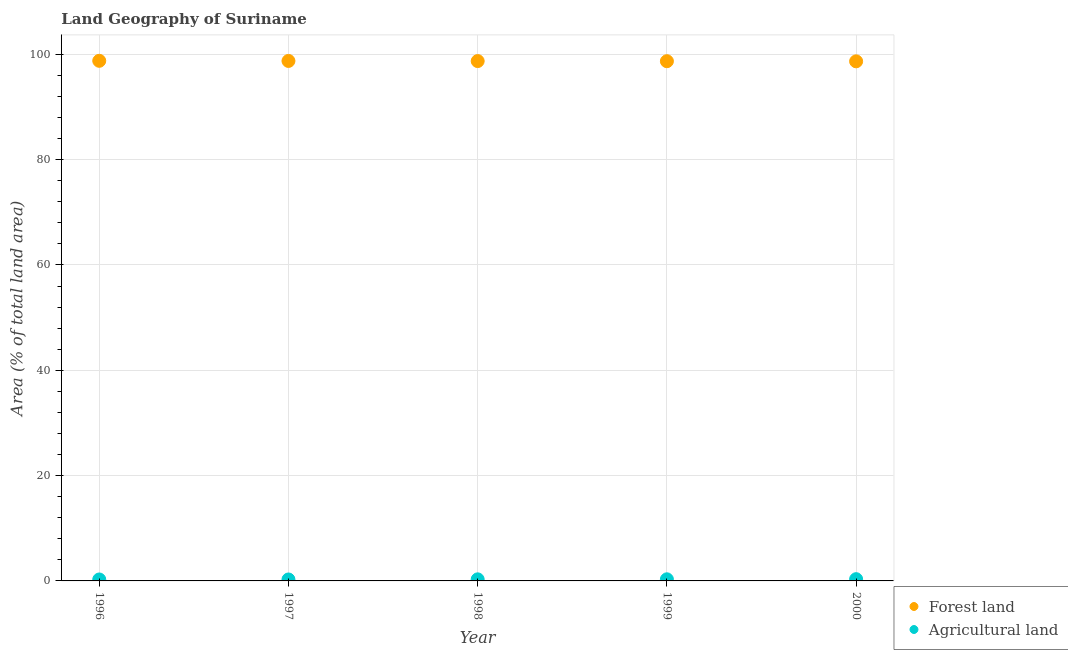What is the percentage of land area under agriculture in 1997?
Keep it short and to the point. 0.28. Across all years, what is the maximum percentage of land area under agriculture?
Make the answer very short. 0.33. Across all years, what is the minimum percentage of land area under forests?
Make the answer very short. 98.66. What is the total percentage of land area under forests in the graph?
Give a very brief answer. 493.55. What is the difference between the percentage of land area under forests in 1996 and that in 1998?
Ensure brevity in your answer.  0.05. What is the difference between the percentage of land area under forests in 2000 and the percentage of land area under agriculture in 1998?
Your response must be concise. 98.36. What is the average percentage of land area under forests per year?
Make the answer very short. 98.71. In the year 1996, what is the difference between the percentage of land area under agriculture and percentage of land area under forests?
Your answer should be very brief. -98.48. What is the ratio of the percentage of land area under forests in 1997 to that in 2000?
Offer a very short reply. 1. Is the percentage of land area under agriculture in 1997 less than that in 1999?
Offer a terse response. Yes. Is the difference between the percentage of land area under forests in 1999 and 2000 greater than the difference between the percentage of land area under agriculture in 1999 and 2000?
Your answer should be compact. Yes. What is the difference between the highest and the second highest percentage of land area under agriculture?
Ensure brevity in your answer.  0.03. What is the difference between the highest and the lowest percentage of land area under agriculture?
Your response must be concise. 0.06. In how many years, is the percentage of land area under agriculture greater than the average percentage of land area under agriculture taken over all years?
Your response must be concise. 3. Is the sum of the percentage of land area under agriculture in 1996 and 1998 greater than the maximum percentage of land area under forests across all years?
Keep it short and to the point. No. Is the percentage of land area under forests strictly greater than the percentage of land area under agriculture over the years?
Your answer should be very brief. Yes. What is the difference between two consecutive major ticks on the Y-axis?
Give a very brief answer. 20. How many legend labels are there?
Your answer should be very brief. 2. How are the legend labels stacked?
Keep it short and to the point. Vertical. What is the title of the graph?
Give a very brief answer. Land Geography of Suriname. Does "Males" appear as one of the legend labels in the graph?
Your response must be concise. No. What is the label or title of the X-axis?
Provide a succinct answer. Year. What is the label or title of the Y-axis?
Your answer should be compact. Area (% of total land area). What is the Area (% of total land area) of Forest land in 1996?
Offer a terse response. 98.76. What is the Area (% of total land area) in Agricultural land in 1996?
Your answer should be compact. 0.28. What is the Area (% of total land area) of Forest land in 1997?
Your answer should be very brief. 98.74. What is the Area (% of total land area) of Agricultural land in 1997?
Your answer should be very brief. 0.28. What is the Area (% of total land area) of Forest land in 1998?
Your answer should be very brief. 98.71. What is the Area (% of total land area) of Agricultural land in 1998?
Your answer should be compact. 0.3. What is the Area (% of total land area) in Forest land in 1999?
Your response must be concise. 98.69. What is the Area (% of total land area) of Agricultural land in 1999?
Give a very brief answer. 0.31. What is the Area (% of total land area) in Forest land in 2000?
Keep it short and to the point. 98.66. What is the Area (% of total land area) of Agricultural land in 2000?
Your answer should be compact. 0.33. Across all years, what is the maximum Area (% of total land area) of Forest land?
Give a very brief answer. 98.76. Across all years, what is the maximum Area (% of total land area) of Agricultural land?
Your answer should be very brief. 0.33. Across all years, what is the minimum Area (% of total land area) of Forest land?
Make the answer very short. 98.66. Across all years, what is the minimum Area (% of total land area) in Agricultural land?
Provide a short and direct response. 0.28. What is the total Area (% of total land area) in Forest land in the graph?
Offer a very short reply. 493.55. What is the total Area (% of total land area) in Agricultural land in the graph?
Your response must be concise. 1.49. What is the difference between the Area (% of total land area) in Forest land in 1996 and that in 1997?
Make the answer very short. 0.03. What is the difference between the Area (% of total land area) in Agricultural land in 1996 and that in 1997?
Ensure brevity in your answer.  0. What is the difference between the Area (% of total land area) in Forest land in 1996 and that in 1998?
Provide a short and direct response. 0.05. What is the difference between the Area (% of total land area) in Agricultural land in 1996 and that in 1998?
Offer a very short reply. -0.03. What is the difference between the Area (% of total land area) in Forest land in 1996 and that in 1999?
Your response must be concise. 0.07. What is the difference between the Area (% of total land area) of Agricultural land in 1996 and that in 1999?
Give a very brief answer. -0.03. What is the difference between the Area (% of total land area) in Forest land in 1996 and that in 2000?
Keep it short and to the point. 0.1. What is the difference between the Area (% of total land area) of Agricultural land in 1996 and that in 2000?
Ensure brevity in your answer.  -0.06. What is the difference between the Area (% of total land area) of Forest land in 1997 and that in 1998?
Make the answer very short. 0.03. What is the difference between the Area (% of total land area) of Agricultural land in 1997 and that in 1998?
Your answer should be compact. -0.03. What is the difference between the Area (% of total land area) in Forest land in 1997 and that in 1999?
Keep it short and to the point. 0.05. What is the difference between the Area (% of total land area) in Agricultural land in 1997 and that in 1999?
Offer a terse response. -0.03. What is the difference between the Area (% of total land area) of Forest land in 1997 and that in 2000?
Provide a succinct answer. 0.07. What is the difference between the Area (% of total land area) of Agricultural land in 1997 and that in 2000?
Offer a very short reply. -0.06. What is the difference between the Area (% of total land area) in Forest land in 1998 and that in 1999?
Keep it short and to the point. 0.03. What is the difference between the Area (% of total land area) in Agricultural land in 1998 and that in 1999?
Offer a terse response. -0.01. What is the difference between the Area (% of total land area) of Forest land in 1998 and that in 2000?
Offer a terse response. 0.05. What is the difference between the Area (% of total land area) of Agricultural land in 1998 and that in 2000?
Your response must be concise. -0.03. What is the difference between the Area (% of total land area) of Forest land in 1999 and that in 2000?
Offer a terse response. 0.03. What is the difference between the Area (% of total land area) of Agricultural land in 1999 and that in 2000?
Ensure brevity in your answer.  -0.03. What is the difference between the Area (% of total land area) in Forest land in 1996 and the Area (% of total land area) in Agricultural land in 1997?
Provide a short and direct response. 98.48. What is the difference between the Area (% of total land area) in Forest land in 1996 and the Area (% of total land area) in Agricultural land in 1998?
Your answer should be compact. 98.46. What is the difference between the Area (% of total land area) in Forest land in 1996 and the Area (% of total land area) in Agricultural land in 1999?
Make the answer very short. 98.45. What is the difference between the Area (% of total land area) of Forest land in 1996 and the Area (% of total land area) of Agricultural land in 2000?
Your answer should be compact. 98.43. What is the difference between the Area (% of total land area) of Forest land in 1997 and the Area (% of total land area) of Agricultural land in 1998?
Offer a terse response. 98.43. What is the difference between the Area (% of total land area) of Forest land in 1997 and the Area (% of total land area) of Agricultural land in 1999?
Make the answer very short. 98.43. What is the difference between the Area (% of total land area) in Forest land in 1997 and the Area (% of total land area) in Agricultural land in 2000?
Your response must be concise. 98.4. What is the difference between the Area (% of total land area) in Forest land in 1998 and the Area (% of total land area) in Agricultural land in 1999?
Your answer should be very brief. 98.4. What is the difference between the Area (% of total land area) of Forest land in 1998 and the Area (% of total land area) of Agricultural land in 2000?
Keep it short and to the point. 98.38. What is the difference between the Area (% of total land area) of Forest land in 1999 and the Area (% of total land area) of Agricultural land in 2000?
Give a very brief answer. 98.35. What is the average Area (% of total land area) of Forest land per year?
Make the answer very short. 98.71. What is the average Area (% of total land area) of Agricultural land per year?
Offer a very short reply. 0.3. In the year 1996, what is the difference between the Area (% of total land area) of Forest land and Area (% of total land area) of Agricultural land?
Keep it short and to the point. 98.48. In the year 1997, what is the difference between the Area (% of total land area) in Forest land and Area (% of total land area) in Agricultural land?
Offer a terse response. 98.46. In the year 1998, what is the difference between the Area (% of total land area) in Forest land and Area (% of total land area) in Agricultural land?
Your answer should be very brief. 98.41. In the year 1999, what is the difference between the Area (% of total land area) in Forest land and Area (% of total land area) in Agricultural land?
Your answer should be compact. 98.38. In the year 2000, what is the difference between the Area (% of total land area) in Forest land and Area (% of total land area) in Agricultural land?
Your answer should be compact. 98.33. What is the ratio of the Area (% of total land area) in Agricultural land in 1996 to that in 1997?
Keep it short and to the point. 1. What is the ratio of the Area (% of total land area) of Forest land in 1996 to that in 1998?
Your response must be concise. 1. What is the ratio of the Area (% of total land area) in Agricultural land in 1996 to that in 1998?
Ensure brevity in your answer.  0.91. What is the ratio of the Area (% of total land area) of Agricultural land in 1996 to that in 1999?
Offer a very short reply. 0.9. What is the ratio of the Area (% of total land area) of Forest land in 1996 to that in 2000?
Your response must be concise. 1. What is the ratio of the Area (% of total land area) in Agricultural land in 1996 to that in 2000?
Your answer should be very brief. 0.83. What is the ratio of the Area (% of total land area) of Agricultural land in 1997 to that in 1998?
Give a very brief answer. 0.91. What is the ratio of the Area (% of total land area) of Agricultural land in 1997 to that in 1999?
Keep it short and to the point. 0.9. What is the ratio of the Area (% of total land area) of Agricultural land in 1997 to that in 2000?
Your response must be concise. 0.83. What is the ratio of the Area (% of total land area) of Forest land in 1998 to that in 1999?
Offer a terse response. 1. What is the ratio of the Area (% of total land area) in Agricultural land in 1998 to that in 1999?
Give a very brief answer. 0.98. What is the ratio of the Area (% of total land area) of Forest land in 1998 to that in 2000?
Make the answer very short. 1. What is the ratio of the Area (% of total land area) of Agricultural land in 1998 to that in 2000?
Ensure brevity in your answer.  0.9. What is the ratio of the Area (% of total land area) of Forest land in 1999 to that in 2000?
Offer a very short reply. 1. What is the difference between the highest and the second highest Area (% of total land area) in Forest land?
Offer a very short reply. 0.03. What is the difference between the highest and the second highest Area (% of total land area) in Agricultural land?
Give a very brief answer. 0.03. What is the difference between the highest and the lowest Area (% of total land area) in Agricultural land?
Offer a terse response. 0.06. 